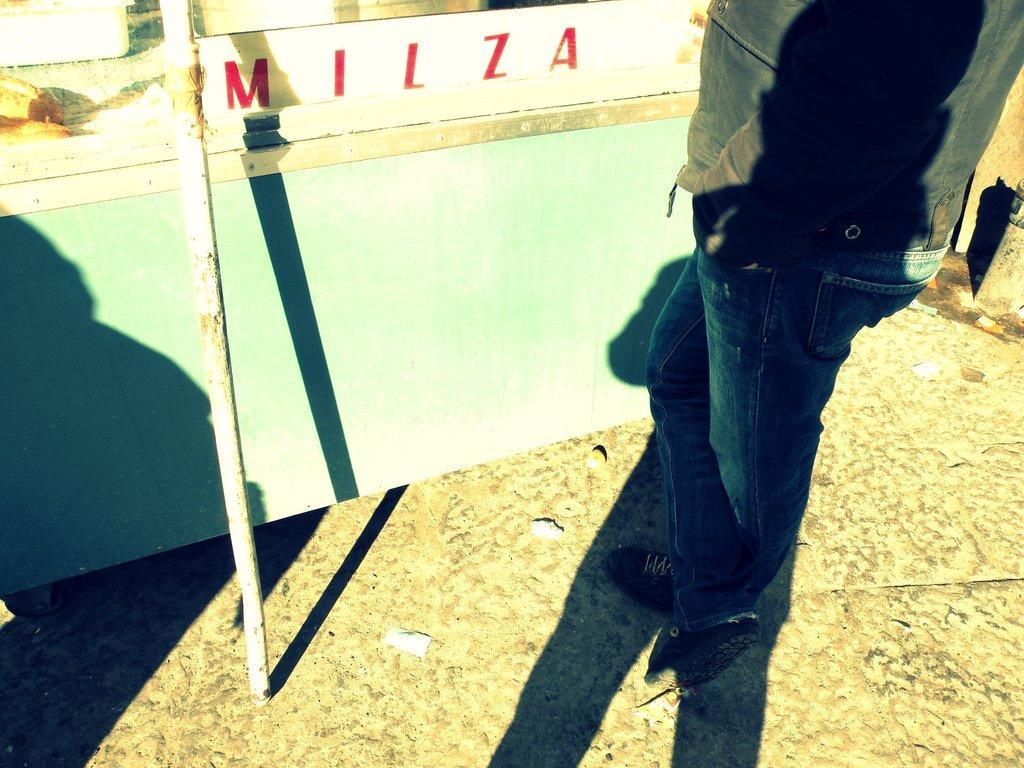In one or two sentences, can you explain what this image depicts? In this image we can see a person is standing on the ground, there is a shadow, there is the pole. 